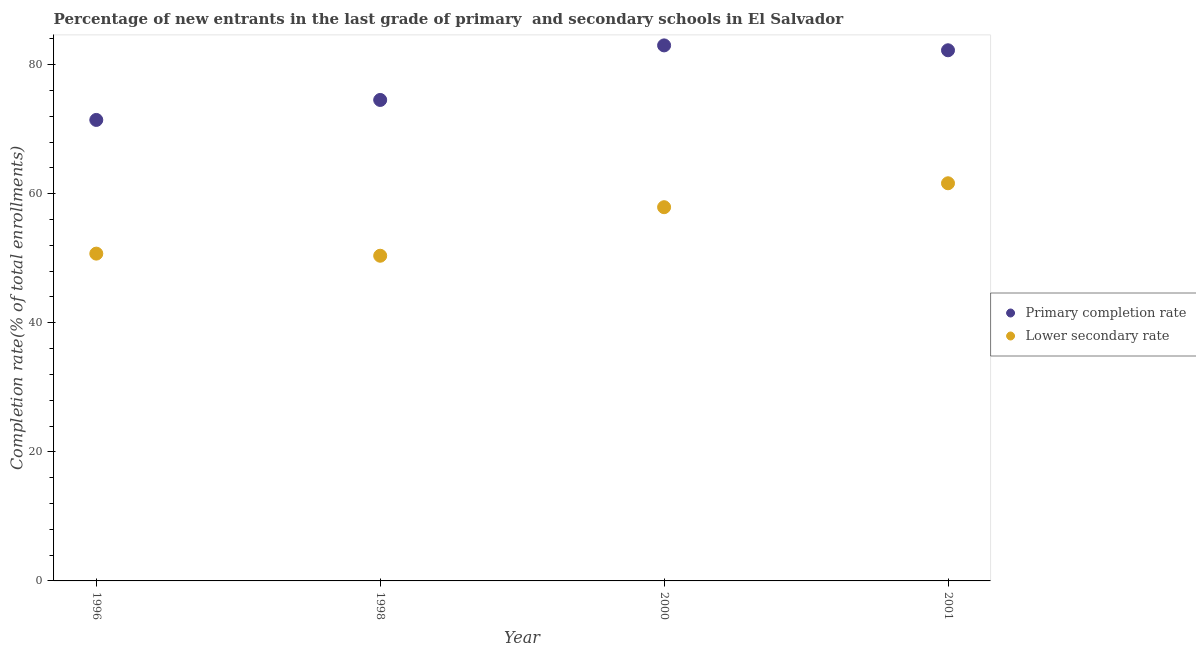How many different coloured dotlines are there?
Provide a succinct answer. 2. Is the number of dotlines equal to the number of legend labels?
Provide a succinct answer. Yes. What is the completion rate in primary schools in 1996?
Your response must be concise. 71.44. Across all years, what is the maximum completion rate in secondary schools?
Make the answer very short. 61.62. Across all years, what is the minimum completion rate in secondary schools?
Offer a terse response. 50.39. In which year was the completion rate in primary schools minimum?
Offer a very short reply. 1996. What is the total completion rate in secondary schools in the graph?
Your response must be concise. 220.65. What is the difference between the completion rate in secondary schools in 1998 and that in 2001?
Your answer should be very brief. -11.23. What is the difference between the completion rate in secondary schools in 2001 and the completion rate in primary schools in 2000?
Keep it short and to the point. -21.37. What is the average completion rate in secondary schools per year?
Provide a short and direct response. 55.16. In the year 1998, what is the difference between the completion rate in secondary schools and completion rate in primary schools?
Give a very brief answer. -24.14. What is the ratio of the completion rate in primary schools in 1998 to that in 2000?
Offer a terse response. 0.9. What is the difference between the highest and the second highest completion rate in secondary schools?
Give a very brief answer. 3.71. What is the difference between the highest and the lowest completion rate in secondary schools?
Give a very brief answer. 11.23. Is the completion rate in secondary schools strictly greater than the completion rate in primary schools over the years?
Provide a short and direct response. No. Is the completion rate in primary schools strictly less than the completion rate in secondary schools over the years?
Keep it short and to the point. No. What is the difference between two consecutive major ticks on the Y-axis?
Your response must be concise. 20. Are the values on the major ticks of Y-axis written in scientific E-notation?
Make the answer very short. No. Where does the legend appear in the graph?
Your answer should be compact. Center right. How many legend labels are there?
Your answer should be very brief. 2. What is the title of the graph?
Ensure brevity in your answer.  Percentage of new entrants in the last grade of primary  and secondary schools in El Salvador. What is the label or title of the Y-axis?
Your response must be concise. Completion rate(% of total enrollments). What is the Completion rate(% of total enrollments) of Primary completion rate in 1996?
Your answer should be compact. 71.44. What is the Completion rate(% of total enrollments) in Lower secondary rate in 1996?
Your answer should be very brief. 50.72. What is the Completion rate(% of total enrollments) of Primary completion rate in 1998?
Your response must be concise. 74.53. What is the Completion rate(% of total enrollments) in Lower secondary rate in 1998?
Your response must be concise. 50.39. What is the Completion rate(% of total enrollments) in Primary completion rate in 2000?
Your answer should be compact. 82.99. What is the Completion rate(% of total enrollments) in Lower secondary rate in 2000?
Ensure brevity in your answer.  57.92. What is the Completion rate(% of total enrollments) of Primary completion rate in 2001?
Make the answer very short. 82.23. What is the Completion rate(% of total enrollments) in Lower secondary rate in 2001?
Provide a succinct answer. 61.62. Across all years, what is the maximum Completion rate(% of total enrollments) of Primary completion rate?
Your response must be concise. 82.99. Across all years, what is the maximum Completion rate(% of total enrollments) of Lower secondary rate?
Give a very brief answer. 61.62. Across all years, what is the minimum Completion rate(% of total enrollments) in Primary completion rate?
Your answer should be compact. 71.44. Across all years, what is the minimum Completion rate(% of total enrollments) of Lower secondary rate?
Make the answer very short. 50.39. What is the total Completion rate(% of total enrollments) in Primary completion rate in the graph?
Provide a succinct answer. 311.2. What is the total Completion rate(% of total enrollments) in Lower secondary rate in the graph?
Provide a succinct answer. 220.65. What is the difference between the Completion rate(% of total enrollments) of Primary completion rate in 1996 and that in 1998?
Keep it short and to the point. -3.1. What is the difference between the Completion rate(% of total enrollments) of Lower secondary rate in 1996 and that in 1998?
Your response must be concise. 0.33. What is the difference between the Completion rate(% of total enrollments) in Primary completion rate in 1996 and that in 2000?
Provide a succinct answer. -11.55. What is the difference between the Completion rate(% of total enrollments) of Lower secondary rate in 1996 and that in 2000?
Provide a succinct answer. -7.19. What is the difference between the Completion rate(% of total enrollments) in Primary completion rate in 1996 and that in 2001?
Your answer should be compact. -10.79. What is the difference between the Completion rate(% of total enrollments) in Lower secondary rate in 1996 and that in 2001?
Provide a short and direct response. -10.9. What is the difference between the Completion rate(% of total enrollments) in Primary completion rate in 1998 and that in 2000?
Your answer should be very brief. -8.45. What is the difference between the Completion rate(% of total enrollments) of Lower secondary rate in 1998 and that in 2000?
Provide a short and direct response. -7.52. What is the difference between the Completion rate(% of total enrollments) in Primary completion rate in 1998 and that in 2001?
Ensure brevity in your answer.  -7.7. What is the difference between the Completion rate(% of total enrollments) in Lower secondary rate in 1998 and that in 2001?
Provide a short and direct response. -11.23. What is the difference between the Completion rate(% of total enrollments) in Primary completion rate in 2000 and that in 2001?
Your answer should be very brief. 0.76. What is the difference between the Completion rate(% of total enrollments) of Lower secondary rate in 2000 and that in 2001?
Give a very brief answer. -3.71. What is the difference between the Completion rate(% of total enrollments) of Primary completion rate in 1996 and the Completion rate(% of total enrollments) of Lower secondary rate in 1998?
Make the answer very short. 21.05. What is the difference between the Completion rate(% of total enrollments) in Primary completion rate in 1996 and the Completion rate(% of total enrollments) in Lower secondary rate in 2000?
Your answer should be compact. 13.52. What is the difference between the Completion rate(% of total enrollments) of Primary completion rate in 1996 and the Completion rate(% of total enrollments) of Lower secondary rate in 2001?
Ensure brevity in your answer.  9.82. What is the difference between the Completion rate(% of total enrollments) of Primary completion rate in 1998 and the Completion rate(% of total enrollments) of Lower secondary rate in 2000?
Make the answer very short. 16.62. What is the difference between the Completion rate(% of total enrollments) of Primary completion rate in 1998 and the Completion rate(% of total enrollments) of Lower secondary rate in 2001?
Offer a very short reply. 12.91. What is the difference between the Completion rate(% of total enrollments) in Primary completion rate in 2000 and the Completion rate(% of total enrollments) in Lower secondary rate in 2001?
Ensure brevity in your answer.  21.37. What is the average Completion rate(% of total enrollments) in Primary completion rate per year?
Offer a very short reply. 77.8. What is the average Completion rate(% of total enrollments) of Lower secondary rate per year?
Your answer should be very brief. 55.16. In the year 1996, what is the difference between the Completion rate(% of total enrollments) of Primary completion rate and Completion rate(% of total enrollments) of Lower secondary rate?
Your response must be concise. 20.72. In the year 1998, what is the difference between the Completion rate(% of total enrollments) in Primary completion rate and Completion rate(% of total enrollments) in Lower secondary rate?
Offer a terse response. 24.14. In the year 2000, what is the difference between the Completion rate(% of total enrollments) in Primary completion rate and Completion rate(% of total enrollments) in Lower secondary rate?
Your answer should be compact. 25.07. In the year 2001, what is the difference between the Completion rate(% of total enrollments) of Primary completion rate and Completion rate(% of total enrollments) of Lower secondary rate?
Provide a short and direct response. 20.61. What is the ratio of the Completion rate(% of total enrollments) in Primary completion rate in 1996 to that in 1998?
Your answer should be compact. 0.96. What is the ratio of the Completion rate(% of total enrollments) of Primary completion rate in 1996 to that in 2000?
Give a very brief answer. 0.86. What is the ratio of the Completion rate(% of total enrollments) in Lower secondary rate in 1996 to that in 2000?
Your answer should be compact. 0.88. What is the ratio of the Completion rate(% of total enrollments) of Primary completion rate in 1996 to that in 2001?
Ensure brevity in your answer.  0.87. What is the ratio of the Completion rate(% of total enrollments) in Lower secondary rate in 1996 to that in 2001?
Your response must be concise. 0.82. What is the ratio of the Completion rate(% of total enrollments) in Primary completion rate in 1998 to that in 2000?
Your answer should be compact. 0.9. What is the ratio of the Completion rate(% of total enrollments) in Lower secondary rate in 1998 to that in 2000?
Provide a succinct answer. 0.87. What is the ratio of the Completion rate(% of total enrollments) in Primary completion rate in 1998 to that in 2001?
Your response must be concise. 0.91. What is the ratio of the Completion rate(% of total enrollments) of Lower secondary rate in 1998 to that in 2001?
Keep it short and to the point. 0.82. What is the ratio of the Completion rate(% of total enrollments) of Primary completion rate in 2000 to that in 2001?
Make the answer very short. 1.01. What is the ratio of the Completion rate(% of total enrollments) in Lower secondary rate in 2000 to that in 2001?
Offer a terse response. 0.94. What is the difference between the highest and the second highest Completion rate(% of total enrollments) in Primary completion rate?
Your answer should be very brief. 0.76. What is the difference between the highest and the second highest Completion rate(% of total enrollments) in Lower secondary rate?
Your response must be concise. 3.71. What is the difference between the highest and the lowest Completion rate(% of total enrollments) in Primary completion rate?
Provide a succinct answer. 11.55. What is the difference between the highest and the lowest Completion rate(% of total enrollments) of Lower secondary rate?
Your response must be concise. 11.23. 